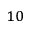<formula> <loc_0><loc_0><loc_500><loc_500>^ { 1 0 }</formula> 